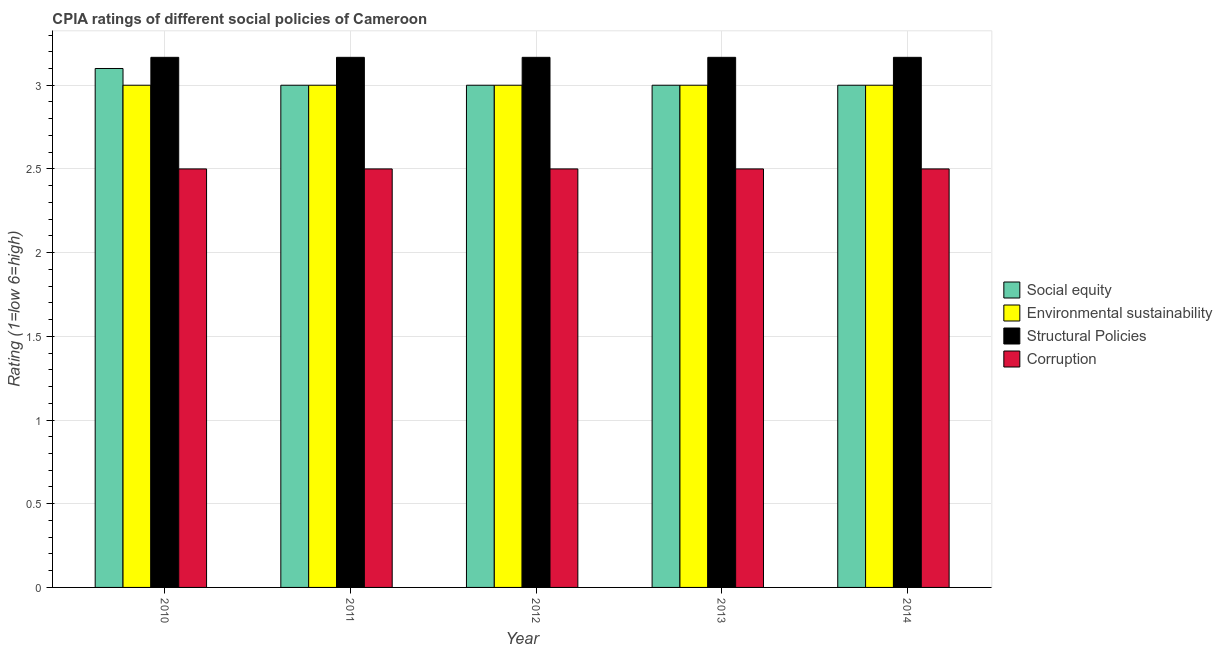How many groups of bars are there?
Make the answer very short. 5. Are the number of bars per tick equal to the number of legend labels?
Keep it short and to the point. Yes. What is the label of the 5th group of bars from the left?
Your answer should be compact. 2014. What is the cpia rating of structural policies in 2011?
Provide a succinct answer. 3.17. Across all years, what is the minimum cpia rating of structural policies?
Make the answer very short. 3.17. In which year was the cpia rating of structural policies minimum?
Give a very brief answer. 2010. What is the total cpia rating of environmental sustainability in the graph?
Your answer should be very brief. 15. In the year 2010, what is the difference between the cpia rating of environmental sustainability and cpia rating of corruption?
Ensure brevity in your answer.  0. What is the ratio of the cpia rating of structural policies in 2010 to that in 2013?
Offer a very short reply. 1. What is the difference between the highest and the second highest cpia rating of social equity?
Ensure brevity in your answer.  0.1. What is the difference between the highest and the lowest cpia rating of social equity?
Give a very brief answer. 0.1. What does the 4th bar from the left in 2013 represents?
Give a very brief answer. Corruption. What does the 2nd bar from the right in 2014 represents?
Your response must be concise. Structural Policies. Is it the case that in every year, the sum of the cpia rating of social equity and cpia rating of environmental sustainability is greater than the cpia rating of structural policies?
Ensure brevity in your answer.  Yes. How many bars are there?
Keep it short and to the point. 20. How many years are there in the graph?
Keep it short and to the point. 5. Are the values on the major ticks of Y-axis written in scientific E-notation?
Offer a very short reply. No. Does the graph contain any zero values?
Your answer should be compact. No. Where does the legend appear in the graph?
Offer a very short reply. Center right. How many legend labels are there?
Your response must be concise. 4. How are the legend labels stacked?
Offer a very short reply. Vertical. What is the title of the graph?
Your response must be concise. CPIA ratings of different social policies of Cameroon. Does "Burnt food" appear as one of the legend labels in the graph?
Offer a very short reply. No. What is the Rating (1=low 6=high) of Structural Policies in 2010?
Give a very brief answer. 3.17. What is the Rating (1=low 6=high) in Corruption in 2010?
Your answer should be compact. 2.5. What is the Rating (1=low 6=high) of Social equity in 2011?
Offer a very short reply. 3. What is the Rating (1=low 6=high) in Environmental sustainability in 2011?
Make the answer very short. 3. What is the Rating (1=low 6=high) of Structural Policies in 2011?
Your answer should be very brief. 3.17. What is the Rating (1=low 6=high) in Corruption in 2011?
Make the answer very short. 2.5. What is the Rating (1=low 6=high) of Social equity in 2012?
Make the answer very short. 3. What is the Rating (1=low 6=high) in Structural Policies in 2012?
Your answer should be very brief. 3.17. What is the Rating (1=low 6=high) of Social equity in 2013?
Offer a terse response. 3. What is the Rating (1=low 6=high) in Structural Policies in 2013?
Make the answer very short. 3.17. What is the Rating (1=low 6=high) in Social equity in 2014?
Offer a terse response. 3. What is the Rating (1=low 6=high) in Environmental sustainability in 2014?
Your answer should be very brief. 3. What is the Rating (1=low 6=high) in Structural Policies in 2014?
Your answer should be very brief. 3.17. What is the Rating (1=low 6=high) of Corruption in 2014?
Provide a succinct answer. 2.5. Across all years, what is the maximum Rating (1=low 6=high) of Social equity?
Your answer should be very brief. 3.1. Across all years, what is the maximum Rating (1=low 6=high) in Structural Policies?
Offer a terse response. 3.17. Across all years, what is the maximum Rating (1=low 6=high) of Corruption?
Offer a very short reply. 2.5. Across all years, what is the minimum Rating (1=low 6=high) in Structural Policies?
Your response must be concise. 3.17. Across all years, what is the minimum Rating (1=low 6=high) in Corruption?
Provide a short and direct response. 2.5. What is the total Rating (1=low 6=high) of Environmental sustainability in the graph?
Offer a terse response. 15. What is the total Rating (1=low 6=high) in Structural Policies in the graph?
Your response must be concise. 15.83. What is the total Rating (1=low 6=high) in Corruption in the graph?
Your answer should be very brief. 12.5. What is the difference between the Rating (1=low 6=high) in Social equity in 2010 and that in 2011?
Your answer should be compact. 0.1. What is the difference between the Rating (1=low 6=high) in Structural Policies in 2010 and that in 2011?
Make the answer very short. 0. What is the difference between the Rating (1=low 6=high) in Corruption in 2010 and that in 2011?
Your answer should be compact. 0. What is the difference between the Rating (1=low 6=high) of Social equity in 2010 and that in 2013?
Give a very brief answer. 0.1. What is the difference between the Rating (1=low 6=high) in Environmental sustainability in 2010 and that in 2013?
Offer a terse response. 0. What is the difference between the Rating (1=low 6=high) of Corruption in 2010 and that in 2013?
Offer a terse response. 0. What is the difference between the Rating (1=low 6=high) in Social equity in 2010 and that in 2014?
Your answer should be very brief. 0.1. What is the difference between the Rating (1=low 6=high) of Structural Policies in 2010 and that in 2014?
Your answer should be compact. 0. What is the difference between the Rating (1=low 6=high) in Corruption in 2010 and that in 2014?
Provide a succinct answer. 0. What is the difference between the Rating (1=low 6=high) in Environmental sustainability in 2011 and that in 2012?
Give a very brief answer. 0. What is the difference between the Rating (1=low 6=high) of Corruption in 2011 and that in 2012?
Provide a short and direct response. 0. What is the difference between the Rating (1=low 6=high) of Corruption in 2011 and that in 2013?
Offer a very short reply. 0. What is the difference between the Rating (1=low 6=high) of Environmental sustainability in 2012 and that in 2013?
Your response must be concise. 0. What is the difference between the Rating (1=low 6=high) in Social equity in 2012 and that in 2014?
Provide a short and direct response. 0. What is the difference between the Rating (1=low 6=high) of Structural Policies in 2012 and that in 2014?
Your answer should be compact. 0. What is the difference between the Rating (1=low 6=high) in Corruption in 2012 and that in 2014?
Provide a short and direct response. 0. What is the difference between the Rating (1=low 6=high) of Structural Policies in 2013 and that in 2014?
Offer a terse response. 0. What is the difference between the Rating (1=low 6=high) of Corruption in 2013 and that in 2014?
Provide a succinct answer. 0. What is the difference between the Rating (1=low 6=high) of Social equity in 2010 and the Rating (1=low 6=high) of Structural Policies in 2011?
Make the answer very short. -0.07. What is the difference between the Rating (1=low 6=high) of Environmental sustainability in 2010 and the Rating (1=low 6=high) of Corruption in 2011?
Make the answer very short. 0.5. What is the difference between the Rating (1=low 6=high) of Social equity in 2010 and the Rating (1=low 6=high) of Environmental sustainability in 2012?
Your response must be concise. 0.1. What is the difference between the Rating (1=low 6=high) of Social equity in 2010 and the Rating (1=low 6=high) of Structural Policies in 2012?
Your answer should be compact. -0.07. What is the difference between the Rating (1=low 6=high) of Environmental sustainability in 2010 and the Rating (1=low 6=high) of Structural Policies in 2012?
Your answer should be compact. -0.17. What is the difference between the Rating (1=low 6=high) of Environmental sustainability in 2010 and the Rating (1=low 6=high) of Corruption in 2012?
Offer a terse response. 0.5. What is the difference between the Rating (1=low 6=high) in Structural Policies in 2010 and the Rating (1=low 6=high) in Corruption in 2012?
Keep it short and to the point. 0.67. What is the difference between the Rating (1=low 6=high) of Social equity in 2010 and the Rating (1=low 6=high) of Structural Policies in 2013?
Offer a very short reply. -0.07. What is the difference between the Rating (1=low 6=high) of Social equity in 2010 and the Rating (1=low 6=high) of Corruption in 2013?
Give a very brief answer. 0.6. What is the difference between the Rating (1=low 6=high) in Environmental sustainability in 2010 and the Rating (1=low 6=high) in Corruption in 2013?
Keep it short and to the point. 0.5. What is the difference between the Rating (1=low 6=high) of Structural Policies in 2010 and the Rating (1=low 6=high) of Corruption in 2013?
Your answer should be very brief. 0.67. What is the difference between the Rating (1=low 6=high) in Social equity in 2010 and the Rating (1=low 6=high) in Structural Policies in 2014?
Make the answer very short. -0.07. What is the difference between the Rating (1=low 6=high) of Social equity in 2010 and the Rating (1=low 6=high) of Corruption in 2014?
Provide a succinct answer. 0.6. What is the difference between the Rating (1=low 6=high) of Environmental sustainability in 2010 and the Rating (1=low 6=high) of Corruption in 2014?
Your answer should be very brief. 0.5. What is the difference between the Rating (1=low 6=high) in Structural Policies in 2010 and the Rating (1=low 6=high) in Corruption in 2014?
Your answer should be compact. 0.67. What is the difference between the Rating (1=low 6=high) in Social equity in 2011 and the Rating (1=low 6=high) in Structural Policies in 2012?
Provide a succinct answer. -0.17. What is the difference between the Rating (1=low 6=high) in Environmental sustainability in 2011 and the Rating (1=low 6=high) in Corruption in 2012?
Make the answer very short. 0.5. What is the difference between the Rating (1=low 6=high) of Social equity in 2011 and the Rating (1=low 6=high) of Corruption in 2013?
Make the answer very short. 0.5. What is the difference between the Rating (1=low 6=high) of Environmental sustainability in 2011 and the Rating (1=low 6=high) of Structural Policies in 2013?
Make the answer very short. -0.17. What is the difference between the Rating (1=low 6=high) of Environmental sustainability in 2011 and the Rating (1=low 6=high) of Corruption in 2013?
Give a very brief answer. 0.5. What is the difference between the Rating (1=low 6=high) of Social equity in 2011 and the Rating (1=low 6=high) of Structural Policies in 2014?
Your answer should be compact. -0.17. What is the difference between the Rating (1=low 6=high) in Environmental sustainability in 2011 and the Rating (1=low 6=high) in Corruption in 2014?
Your response must be concise. 0.5. What is the difference between the Rating (1=low 6=high) in Social equity in 2012 and the Rating (1=low 6=high) in Environmental sustainability in 2013?
Offer a terse response. 0. What is the difference between the Rating (1=low 6=high) of Social equity in 2012 and the Rating (1=low 6=high) of Corruption in 2013?
Give a very brief answer. 0.5. What is the difference between the Rating (1=low 6=high) in Social equity in 2012 and the Rating (1=low 6=high) in Environmental sustainability in 2014?
Your answer should be compact. 0. What is the difference between the Rating (1=low 6=high) of Social equity in 2012 and the Rating (1=low 6=high) of Structural Policies in 2014?
Your response must be concise. -0.17. What is the difference between the Rating (1=low 6=high) in Social equity in 2012 and the Rating (1=low 6=high) in Corruption in 2014?
Provide a succinct answer. 0.5. What is the difference between the Rating (1=low 6=high) in Environmental sustainability in 2012 and the Rating (1=low 6=high) in Structural Policies in 2014?
Make the answer very short. -0.17. What is the difference between the Rating (1=low 6=high) in Environmental sustainability in 2012 and the Rating (1=low 6=high) in Corruption in 2014?
Your response must be concise. 0.5. What is the difference between the Rating (1=low 6=high) of Social equity in 2013 and the Rating (1=low 6=high) of Environmental sustainability in 2014?
Provide a succinct answer. 0. What is the difference between the Rating (1=low 6=high) in Social equity in 2013 and the Rating (1=low 6=high) in Corruption in 2014?
Your response must be concise. 0.5. What is the difference between the Rating (1=low 6=high) in Environmental sustainability in 2013 and the Rating (1=low 6=high) in Structural Policies in 2014?
Your answer should be very brief. -0.17. What is the average Rating (1=low 6=high) in Social equity per year?
Provide a succinct answer. 3.02. What is the average Rating (1=low 6=high) in Structural Policies per year?
Your answer should be compact. 3.17. In the year 2010, what is the difference between the Rating (1=low 6=high) in Social equity and Rating (1=low 6=high) in Structural Policies?
Offer a very short reply. -0.07. In the year 2010, what is the difference between the Rating (1=low 6=high) of Social equity and Rating (1=low 6=high) of Corruption?
Give a very brief answer. 0.6. In the year 2011, what is the difference between the Rating (1=low 6=high) of Social equity and Rating (1=low 6=high) of Environmental sustainability?
Provide a succinct answer. 0. In the year 2011, what is the difference between the Rating (1=low 6=high) in Social equity and Rating (1=low 6=high) in Structural Policies?
Your answer should be very brief. -0.17. In the year 2011, what is the difference between the Rating (1=low 6=high) of Social equity and Rating (1=low 6=high) of Corruption?
Offer a terse response. 0.5. In the year 2011, what is the difference between the Rating (1=low 6=high) in Environmental sustainability and Rating (1=low 6=high) in Corruption?
Provide a succinct answer. 0.5. In the year 2012, what is the difference between the Rating (1=low 6=high) of Environmental sustainability and Rating (1=low 6=high) of Structural Policies?
Give a very brief answer. -0.17. In the year 2012, what is the difference between the Rating (1=low 6=high) of Structural Policies and Rating (1=low 6=high) of Corruption?
Provide a short and direct response. 0.67. In the year 2013, what is the difference between the Rating (1=low 6=high) of Social equity and Rating (1=low 6=high) of Environmental sustainability?
Keep it short and to the point. 0. In the year 2013, what is the difference between the Rating (1=low 6=high) in Social equity and Rating (1=low 6=high) in Corruption?
Provide a succinct answer. 0.5. In the year 2013, what is the difference between the Rating (1=low 6=high) of Environmental sustainability and Rating (1=low 6=high) of Corruption?
Offer a terse response. 0.5. In the year 2013, what is the difference between the Rating (1=low 6=high) of Structural Policies and Rating (1=low 6=high) of Corruption?
Your answer should be very brief. 0.67. In the year 2014, what is the difference between the Rating (1=low 6=high) of Social equity and Rating (1=low 6=high) of Environmental sustainability?
Ensure brevity in your answer.  0. In the year 2014, what is the difference between the Rating (1=low 6=high) of Environmental sustainability and Rating (1=low 6=high) of Corruption?
Give a very brief answer. 0.5. What is the ratio of the Rating (1=low 6=high) of Social equity in 2010 to that in 2011?
Offer a very short reply. 1.03. What is the ratio of the Rating (1=low 6=high) in Environmental sustainability in 2010 to that in 2013?
Keep it short and to the point. 1. What is the ratio of the Rating (1=low 6=high) of Structural Policies in 2010 to that in 2013?
Offer a very short reply. 1. What is the ratio of the Rating (1=low 6=high) in Corruption in 2010 to that in 2013?
Your response must be concise. 1. What is the ratio of the Rating (1=low 6=high) in Corruption in 2010 to that in 2014?
Your response must be concise. 1. What is the ratio of the Rating (1=low 6=high) of Structural Policies in 2011 to that in 2012?
Ensure brevity in your answer.  1. What is the ratio of the Rating (1=low 6=high) in Corruption in 2011 to that in 2012?
Make the answer very short. 1. What is the ratio of the Rating (1=low 6=high) of Environmental sustainability in 2011 to that in 2013?
Your response must be concise. 1. What is the ratio of the Rating (1=low 6=high) of Corruption in 2011 to that in 2013?
Provide a succinct answer. 1. What is the ratio of the Rating (1=low 6=high) in Social equity in 2011 to that in 2014?
Provide a short and direct response. 1. What is the ratio of the Rating (1=low 6=high) of Environmental sustainability in 2011 to that in 2014?
Ensure brevity in your answer.  1. What is the ratio of the Rating (1=low 6=high) of Corruption in 2011 to that in 2014?
Offer a very short reply. 1. What is the ratio of the Rating (1=low 6=high) in Environmental sustainability in 2012 to that in 2013?
Offer a very short reply. 1. What is the ratio of the Rating (1=low 6=high) of Social equity in 2012 to that in 2014?
Your answer should be very brief. 1. What is the ratio of the Rating (1=low 6=high) in Corruption in 2012 to that in 2014?
Offer a terse response. 1. What is the ratio of the Rating (1=low 6=high) in Corruption in 2013 to that in 2014?
Give a very brief answer. 1. What is the difference between the highest and the second highest Rating (1=low 6=high) in Structural Policies?
Provide a succinct answer. 0. What is the difference between the highest and the second highest Rating (1=low 6=high) in Corruption?
Provide a succinct answer. 0. What is the difference between the highest and the lowest Rating (1=low 6=high) of Environmental sustainability?
Provide a succinct answer. 0. 